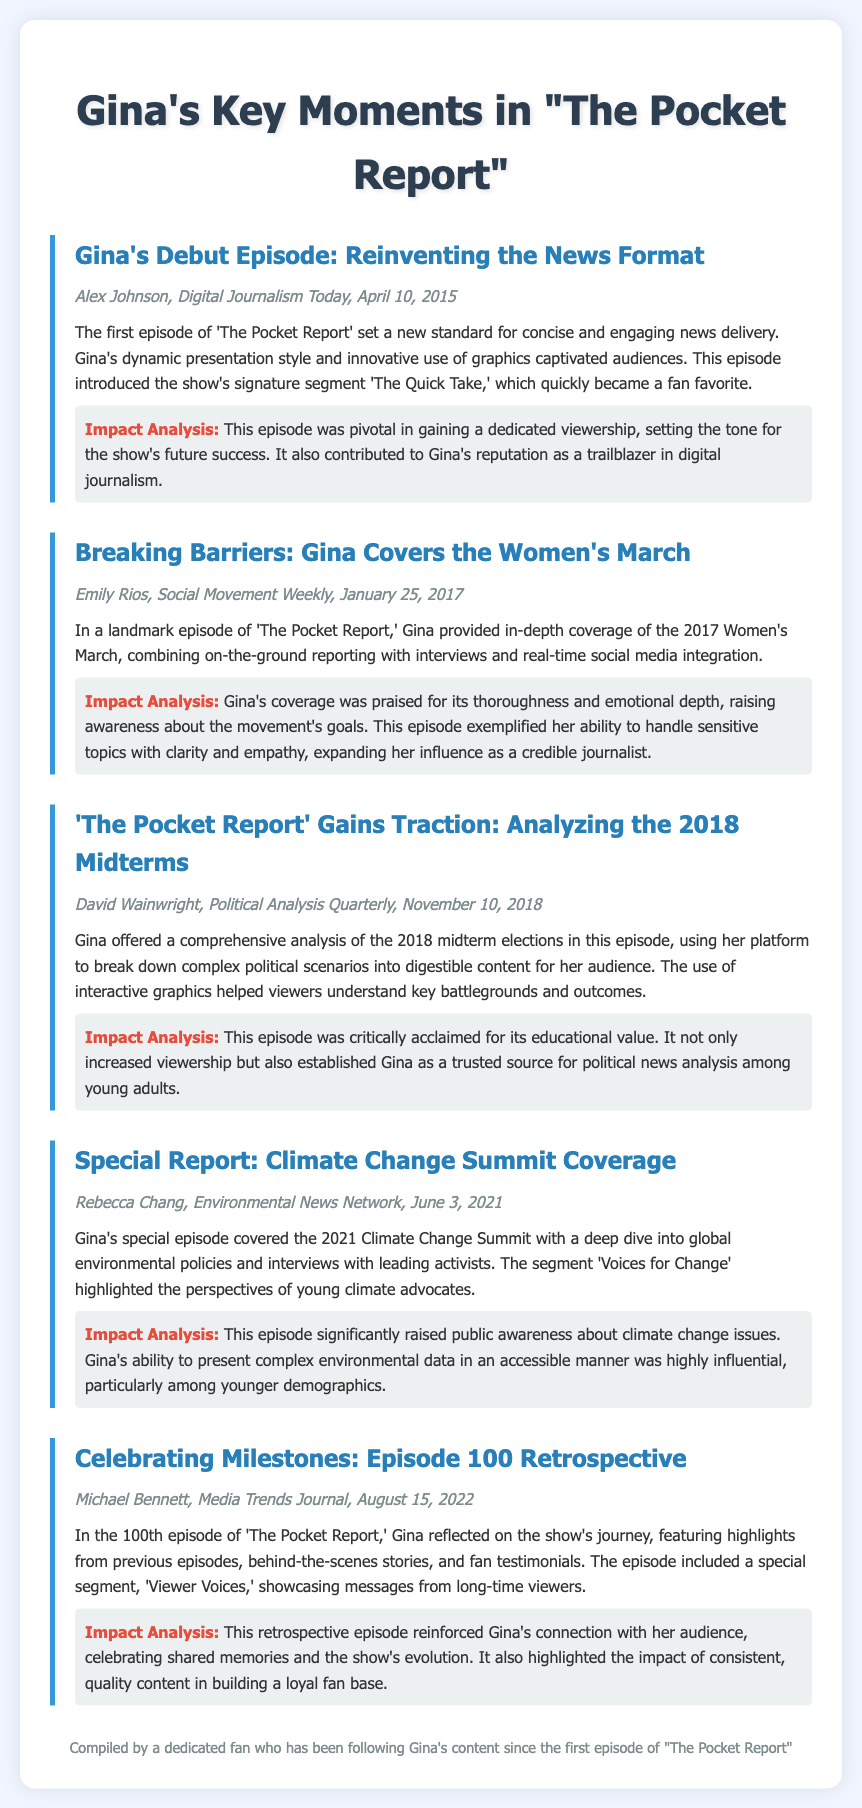What was the title of Gina's debut episode? The title of Gina's debut episode is mentioned as "Gina's Debut Episode: Reinventing the News Format."
Answer: "Gina's Debut Episode: Reinventing the News Format" When did Gina cover the Women's March? The date when Gina covered the Women's March is specified as January 25, 2017.
Answer: January 25, 2017 What is the signature segment introduced in the first episode? The signature segment introduced in the first episode is known as "The Quick Take."
Answer: "The Quick Take" How many episodes had aired by the time of the 100th episode? The 100th episode indicates that there were exactly 100 episodes aired prior to it.
Answer: 100 What was the impact of Gina's analysis of the 2018 midterms? The document states that Gina's analysis established her as a trusted source for political news analysis among young adults.
Answer: Trusted source for political news analysis Which episode focused on climate change issues? The episode that focused on climate change issues is titled "Special Report: Climate Change Summit Coverage."
Answer: "Special Report: Climate Change Summit Coverage" Who authored the coverage of the Women's March? The coverage of the Women's March is authored by Emily Rios according to the reference in the document.
Answer: Emily Rios What segment showcased fan testimonials in the 100th episode? The special segment in the 100th episode that showcased fan testimonials is titled "Viewer Voices."
Answer: "Viewer Voices" 